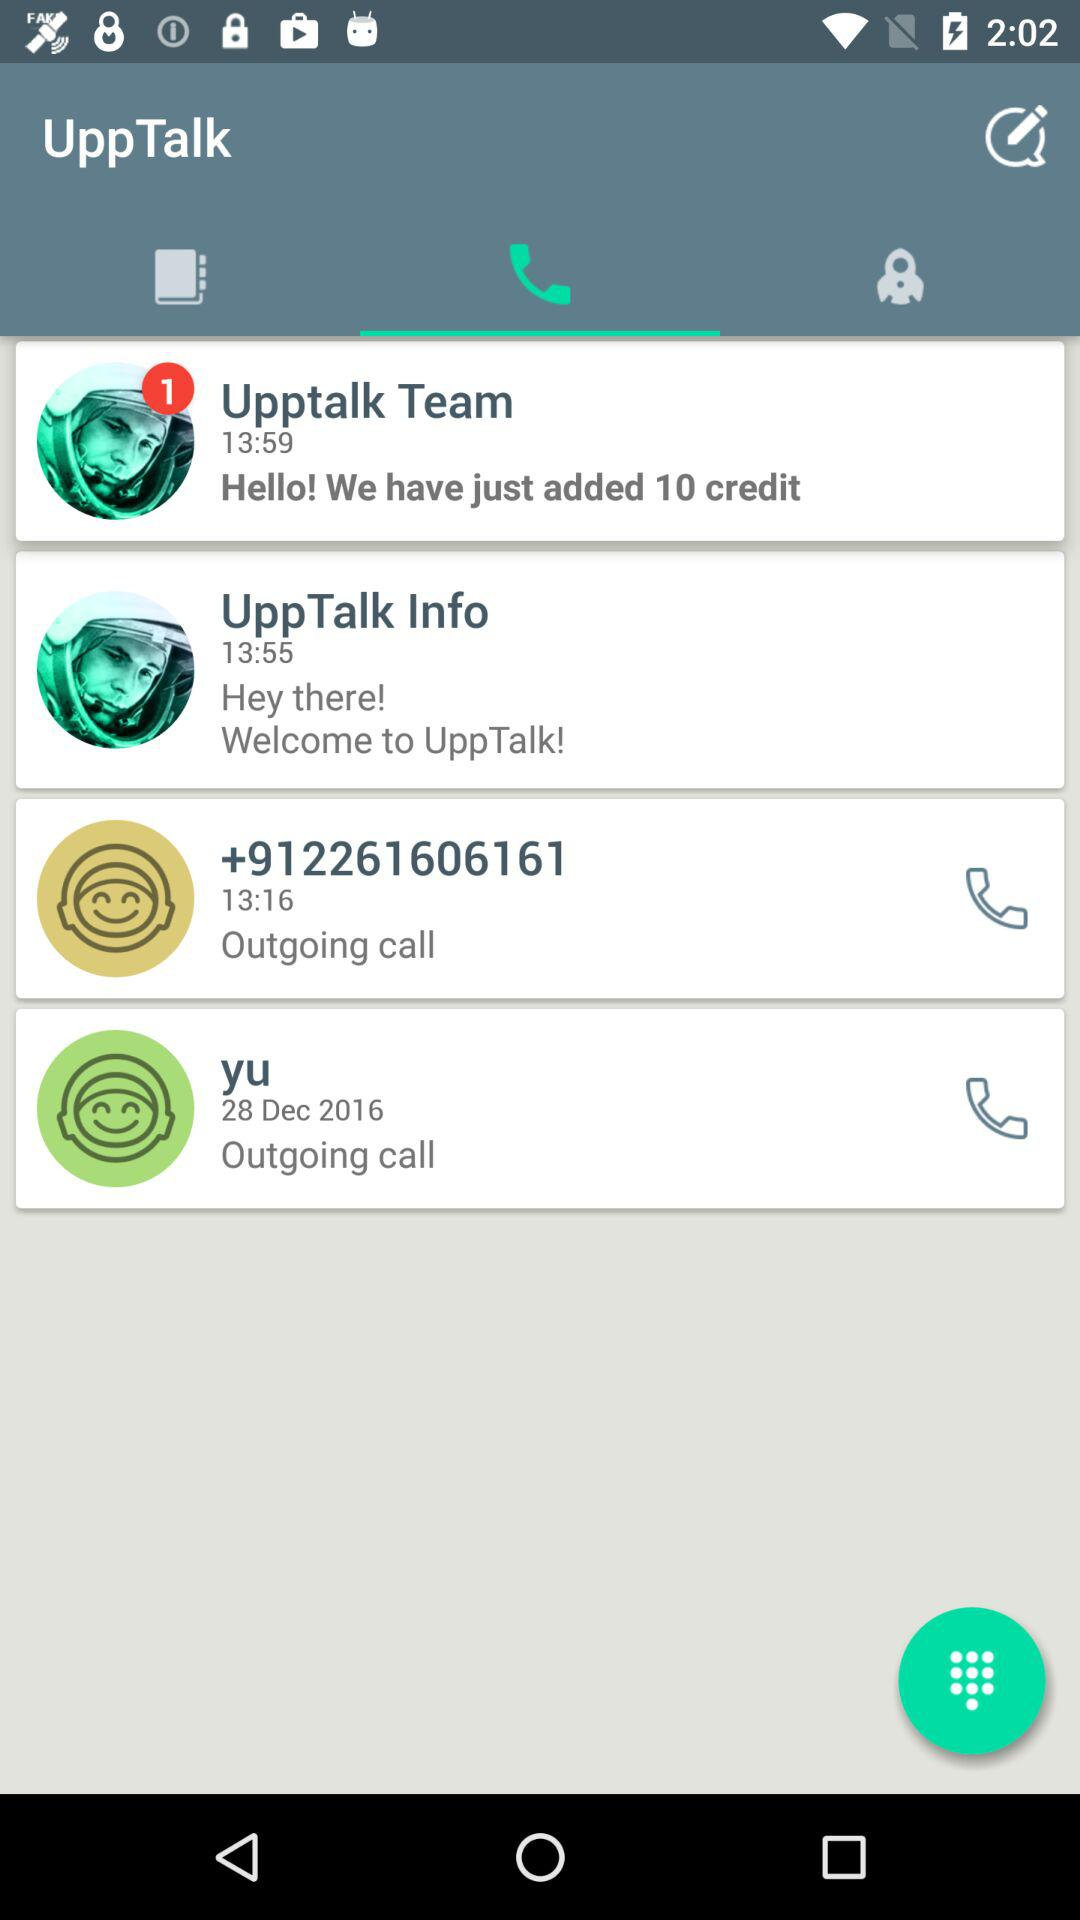How many credits are added by the "Upptalk Team"? The "Upptalk Team" added 10 credits. 